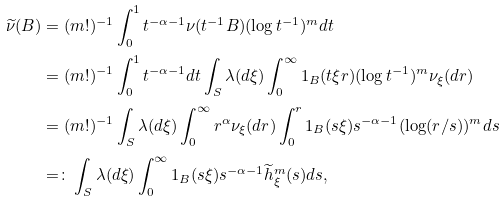Convert formula to latex. <formula><loc_0><loc_0><loc_500><loc_500>\widetilde { \nu } ( B ) & = ( m ! ) ^ { - 1 } \int _ { 0 } ^ { 1 } t ^ { - \alpha - 1 } \nu ( t ^ { - 1 } B ) ( \log t ^ { - 1 } ) ^ { m } d t \\ & = ( m ! ) ^ { - 1 } \int _ { 0 } ^ { 1 } t ^ { - \alpha - 1 } d t \int _ { S } \lambda ( d \xi ) \int _ { 0 } ^ { \infty } 1 _ { B } ( t \xi r ) ( \log t ^ { - 1 } ) ^ { m } \nu _ { \xi } ( d r ) \\ & = ( m ! ) ^ { - 1 } \int _ { S } \lambda ( d \xi ) \int _ { 0 } ^ { \infty } r ^ { \alpha } \nu _ { \xi } ( d r ) \int _ { 0 } ^ { r } 1 _ { B } ( s \xi ) s ^ { - \alpha - 1 } ( \log ( r / s ) ) ^ { m } d s \\ & = \colon \int _ { S } \lambda ( d \xi ) \int _ { 0 } ^ { \infty } 1 _ { B } ( s \xi ) s ^ { - \alpha - 1 } \widetilde { h } ^ { m } _ { \xi } ( s ) d s ,</formula> 